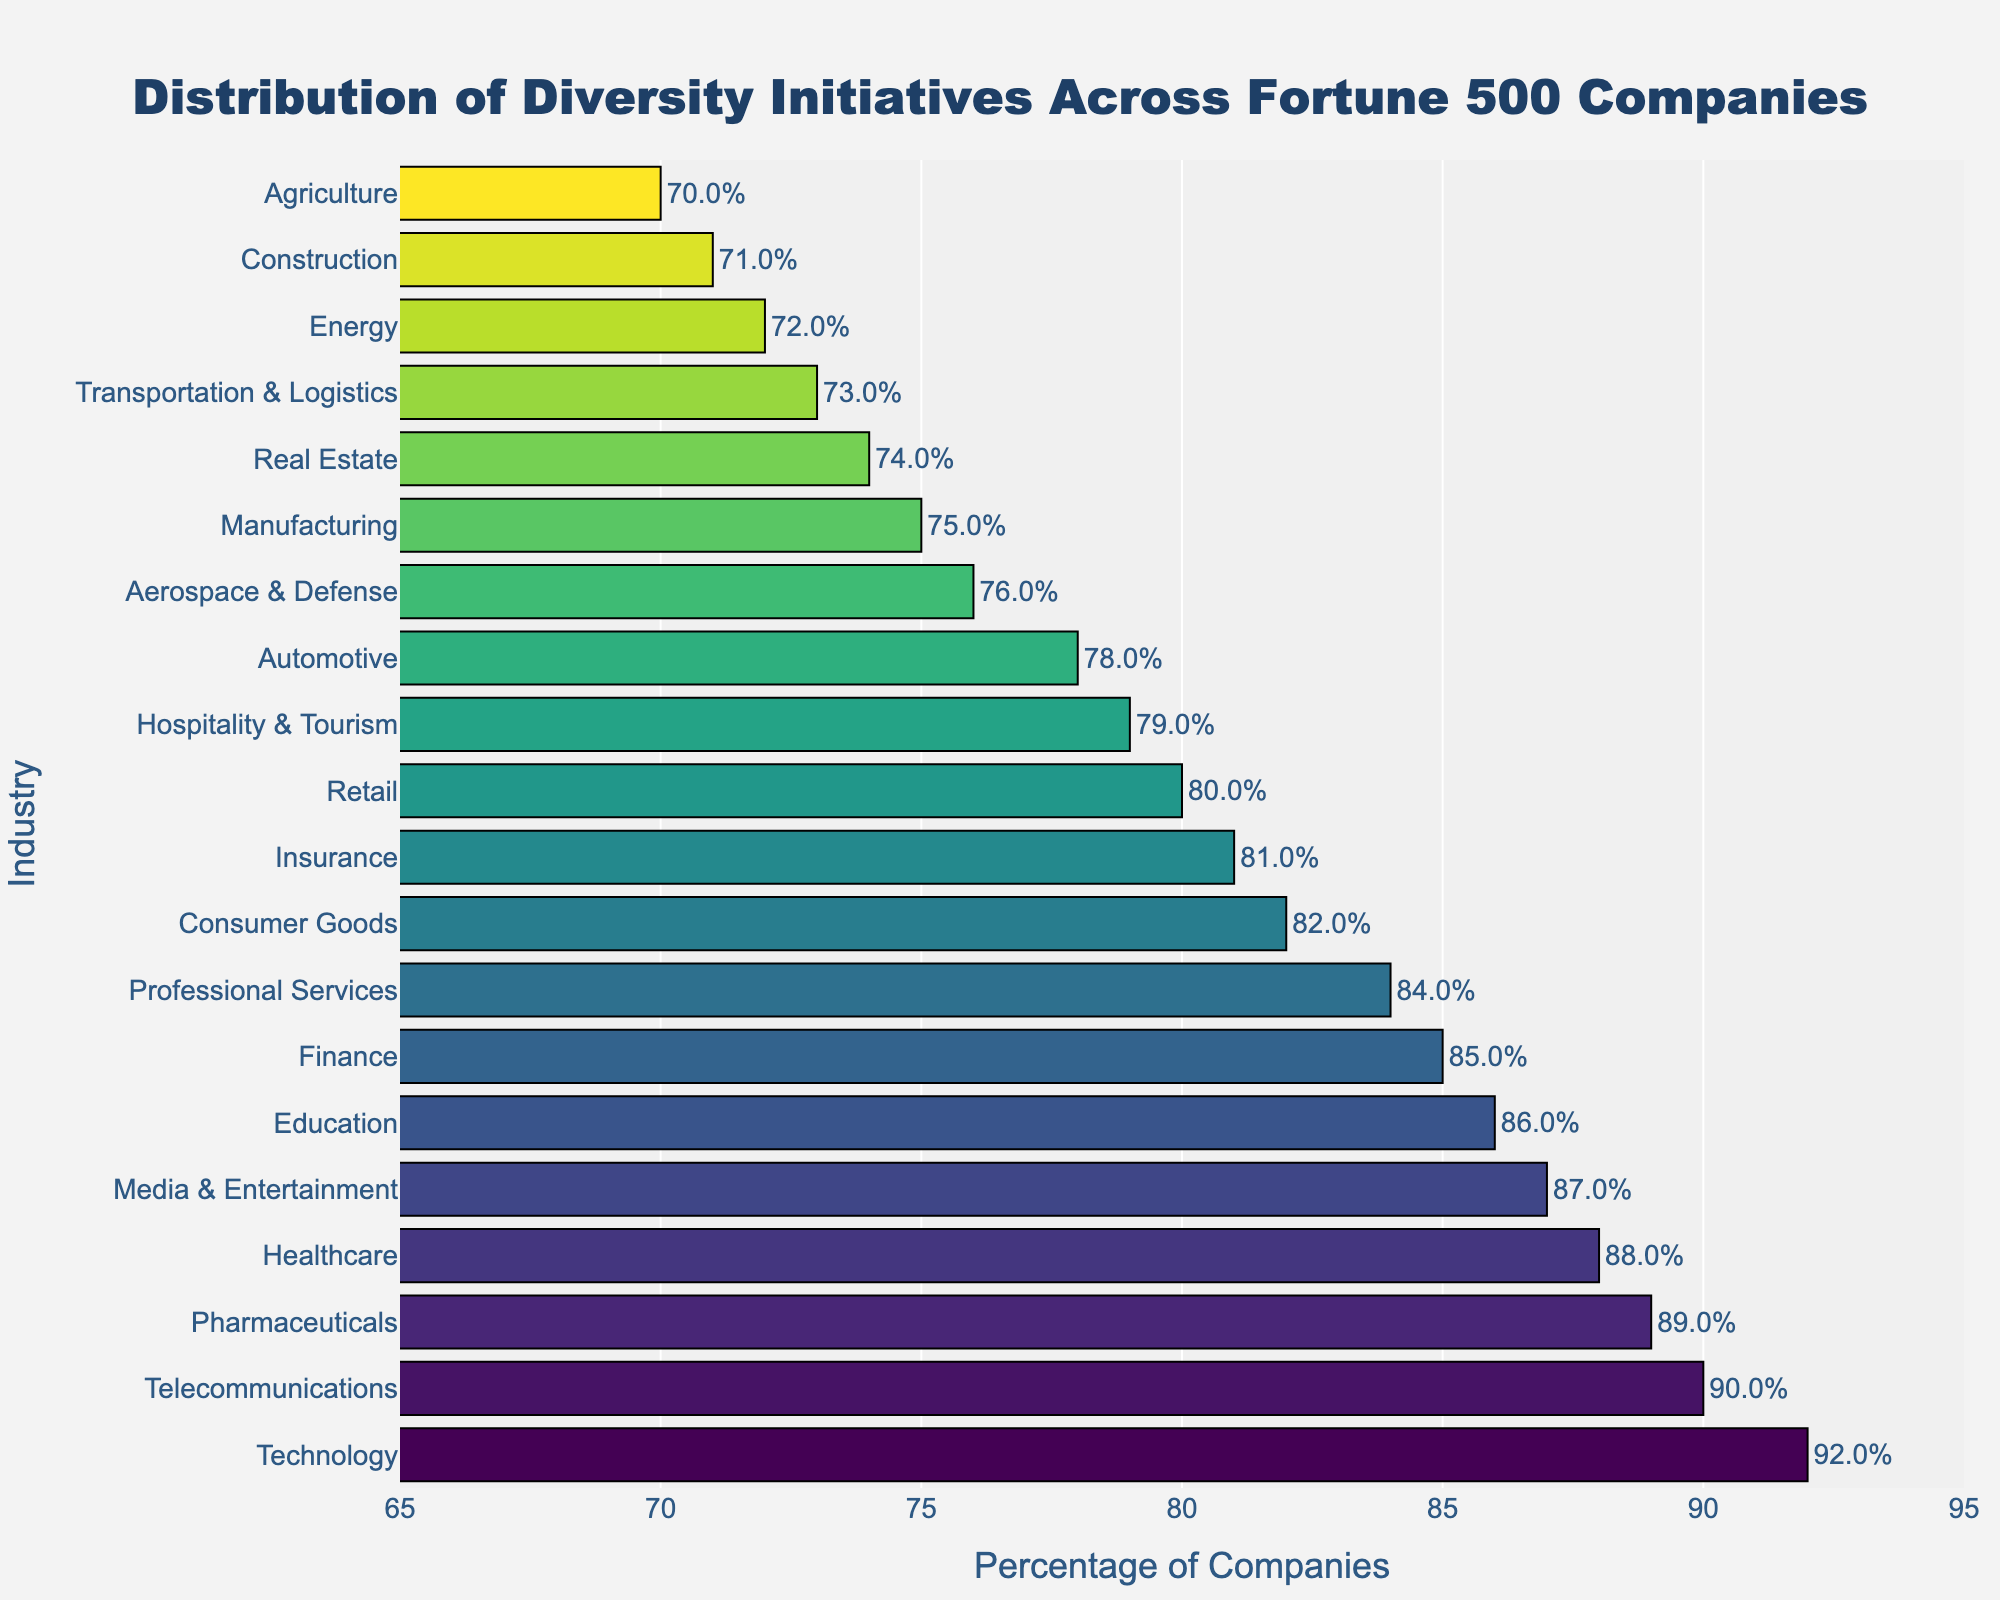Which industry has the highest percentage of companies with diversity initiatives? The bar that extends the furthest to the right indicates the highest percentage. In this figure, the Technology industry has the longest bar.
Answer: Technology Which industry has the lowest percentage of companies with diversity initiatives? The bar that is the shortest and closest to the left indicates the lowest percentage. In this figure, the Agriculture industry has the shortest bar.
Answer: Agriculture How does the percentage in the Finance industry compare to that in the Healthcare industry? The Healthcare bar is slightly longer than the Finance bar, indicating a higher percentage. Specifically, Healthcare is 88% while Finance is 85%.
Answer: Healthcare has a higher percentage What is the difference in the percentage of companies with diversity initiatives between the top two industries? The top two industries are Technology (92%) and Telecommunications (90%). The difference is calculated as 92% - 90%.
Answer: 2% What is the approximate average percentage of companies with diversity initiatives for the Technology, Healthcare, and Finance industries? The percentages for these industries are Technology (92%), Healthcare (88%), and Finance (85%). The average is calculated as (92 + 88 + 85) / 3.
Answer: 88.33% Which three industries have the closest percentages of companies with diversity initiatives? The percentages need to be compared to find the closest ones. Retail (80%), Consumer Goods (82%), and Insurance (81%) are very close to each other.
Answer: Retail, Consumer Goods, and Insurance Are there more industries with percentages above 80% or below 80%? Count the number of industries above and below 80%. There are 12 industries above 80% and 8 industries below 80%.
Answer: Above 80% What is the median percentage of companies with diversity initiatives across all industries? Arrange the percentages in ascending order and find the middle value (or average of the two middle values if even count). Middle values are 81% and 82%, so median is (81 + 82) / 2.
Answer: 81.5% How does the percentage of diversity initiatives in the Education industry compare to the overall median? The Education industry is at 86%, which is higher than the median value of 81.5%.
Answer: Higher Which industries have a percentage of companies with diversity initiatives higher than 80% but less than 90%? Identify the bars that fall within the 80% to 90% range. These are Healthcare (88%), Finance (85%), Retail (80%), Consumer Goods (82%), Pharmaceuticals (89%), Media & Entertainment (87%), Insurance (81%), Hospitality & Tourism (79%), Education (86%), Professional Services (84%).
Answer: Healthcare, Finance, Consumer Goods, Pharmaceuticals, Media & Entertainment, Insurance, Education, Professional Services 